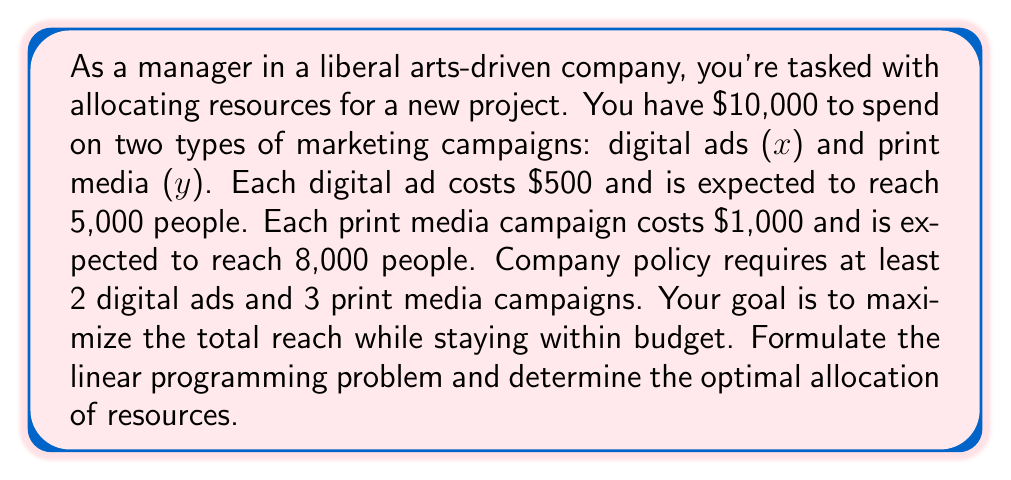Could you help me with this problem? Let's approach this step-by-step:

1) Define variables:
   x = number of digital ad campaigns
   y = number of print media campaigns

2) Objective function:
   Maximize reach: $Z = 5000x + 8000y$

3) Constraints:
   Budget: $500x + 1000y \leq 10000$
   Minimum requirements: $x \geq 2$ and $y \geq 3$
   Non-negativity: $x, y \geq 0$

4) Formulate the linear programming problem:
   Maximize $Z = 5000x + 8000y$
   Subject to:
   $500x + 1000y \leq 10000$
   $x \geq 2$
   $y \geq 3$
   $x, y \geq 0$

5) Solve graphically or using the simplex method:
   The feasible region is bounded by the lines:
   $500x + 1000y = 10000$
   $x = 2$
   $y = 3$

6) The optimal solution will be at one of the corner points. Let's evaluate:
   Point 1: (2, 3) -> Z = 34,000
   Point 2: (2, 7) -> Z = 66,000
   Point 3: (14, 3) -> Z = 94,000

7) The optimal solution is (14, 3), meaning 14 digital ad campaigns and 3 print media campaigns.

8) Check the solution:
   Budget: $500(14) + 1000(3) = 10000$ (exactly meets the budget)
   Reach: $5000(14) + 8000(3) = 94000$ people

Therefore, the optimal allocation is 14 digital ad campaigns and 3 print media campaigns, reaching a total of 94,000 people.
Answer: 14 digital ads, 3 print media campaigns; 94,000 people reached 